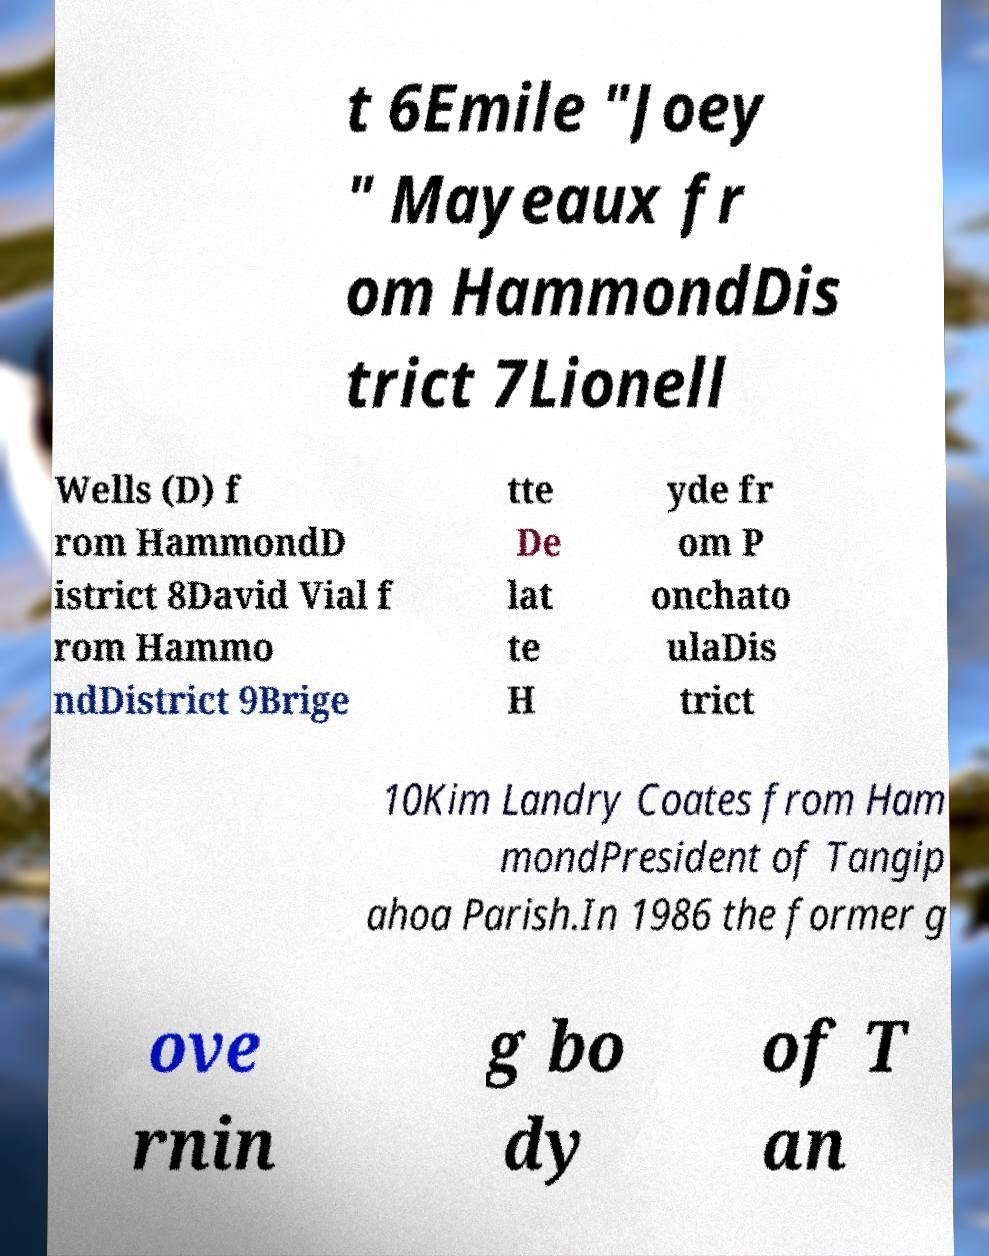Please read and relay the text visible in this image. What does it say? t 6Emile "Joey " Mayeaux fr om HammondDis trict 7Lionell Wells (D) f rom HammondD istrict 8David Vial f rom Hammo ndDistrict 9Brige tte De lat te H yde fr om P onchato ulaDis trict 10Kim Landry Coates from Ham mondPresident of Tangip ahoa Parish.In 1986 the former g ove rnin g bo dy of T an 